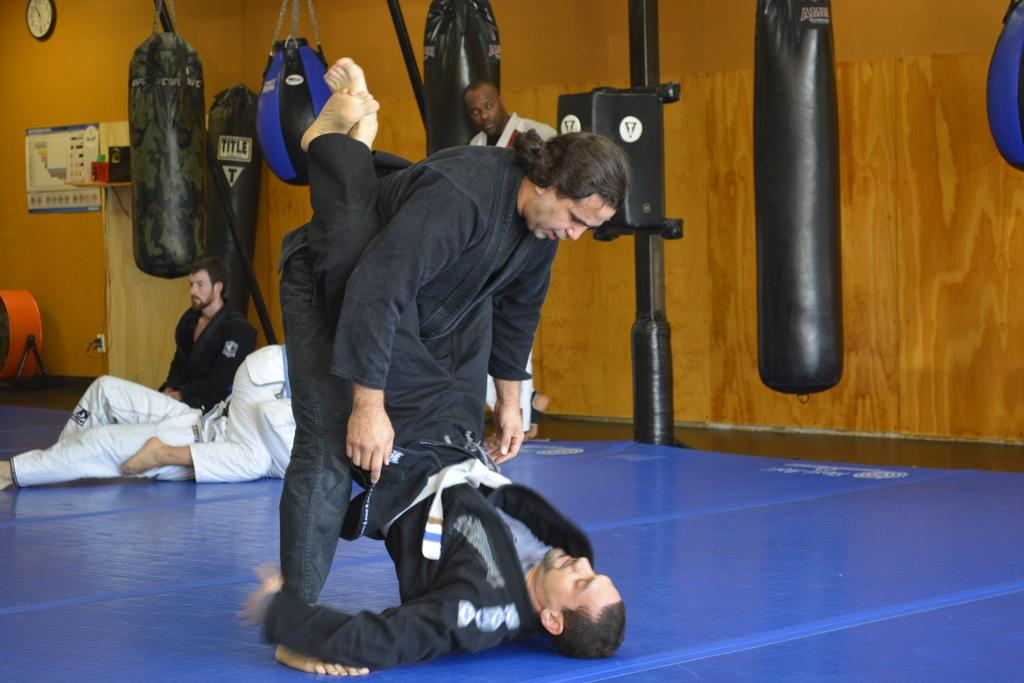What can be seen in the image? There is a group of people in the image. What is visible in the background of the image? There are punching bags and a metal rod in the background of the image. Can you describe any objects on the wall in the image? There is a clock on the wall in the image. What type of cake is being served to the group of people in the image? There is no cake present in the image; it features a group of people, punching bags, a metal rod, and a clock on the wall. 